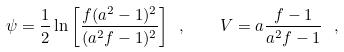<formula> <loc_0><loc_0><loc_500><loc_500>\psi = \frac { 1 } { 2 } \ln { \left [ \frac { f ( a ^ { 2 } - 1 ) ^ { 2 } } { ( a ^ { 2 } f - 1 ) ^ { 2 } } \right ] } \ , \quad V = a \frac { f - 1 } { a ^ { 2 } f - 1 } \ ,</formula> 